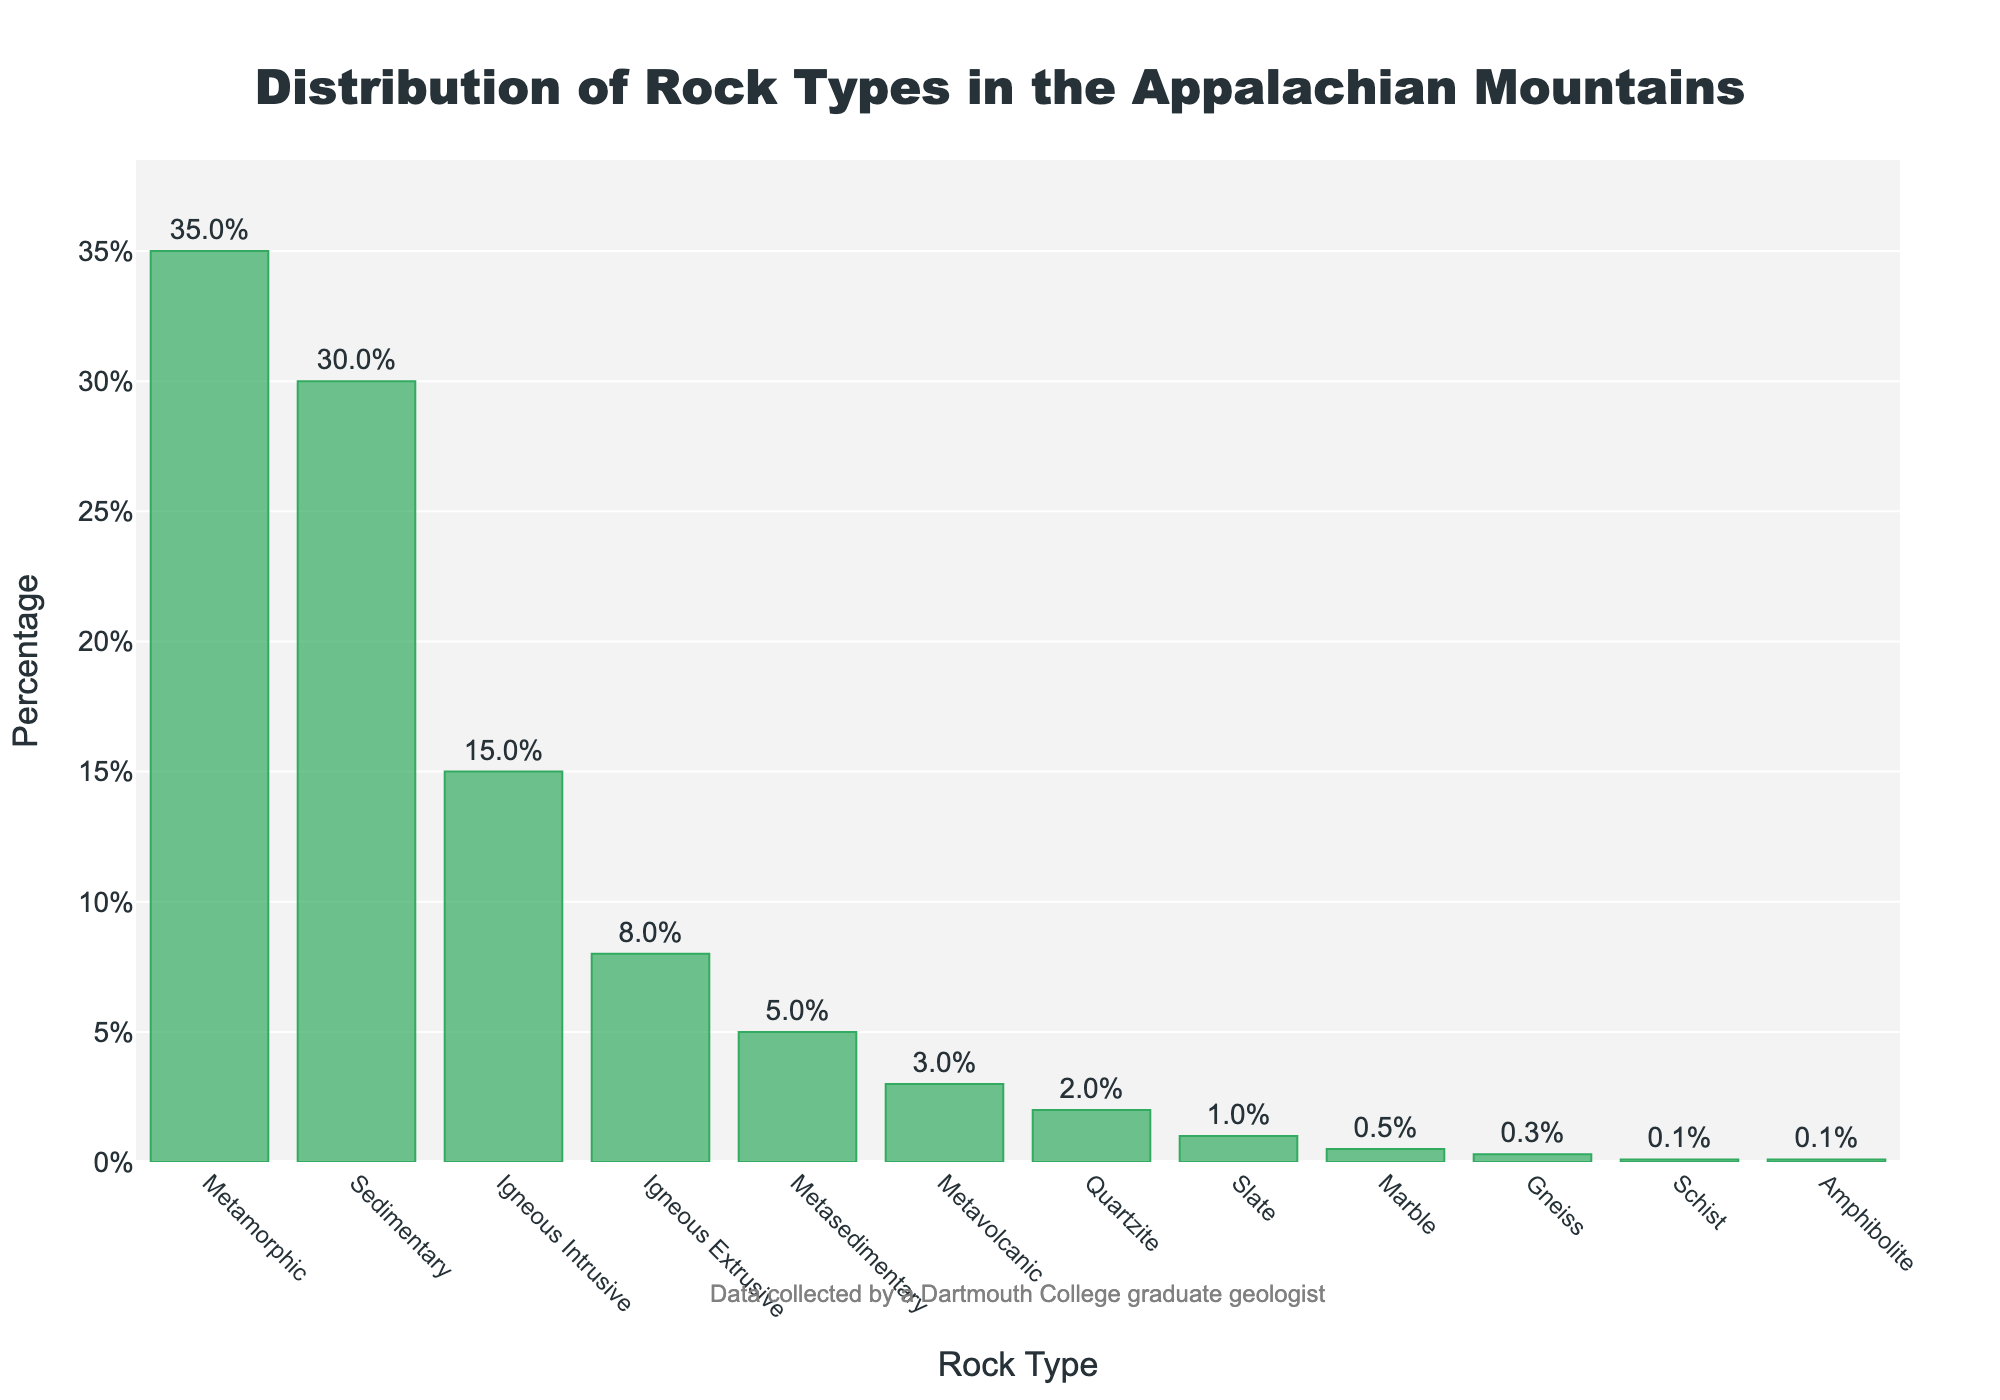What is the most common rock type in the Appalachian Mountains? The highest bar on the chart represents the most common rock type. The tallest bar corresponds to Metamorphic rock, which has the highest percentage.
Answer: Metamorphic Which rock type has the smallest representation in the distribution? The shortest bar on the chart represents the least common rock type. The smallest bar corresponds to Schist and Amphibolite, both with 0.1%.
Answer: Schist and Amphibolite How many rock types have a representation of less than 5% in the distribution? Identify the bars that are less than 5% along the y-axis. There are 7 such bars: Metasedimentary, Metavolcanic, Quartzite, Slate, Marble, Gneiss, Schist, and Amphibolite.
Answer: 7 What is the combined percentage of Igneous Intrusive and Igneous Extrusive rocks? Add the percentage values of Igneous Intrusive (15%) and Igneous Extrusive (8%). 15% + 8% = 23%.
Answer: 23% Compare the percentage representation of Sedimentary and Metasedimentary rocks. Refer to the height of the bars for Sedimentary (30%) and Metasedimentary (5%). Sedimentary rock has a higher percentage.
Answer: Sedimentary Is the percentage of Metamorphic rock greater than the combined percentage of Metasedimentary and Metavolcanic rocks? Metamorphic is 35%. Metasedimentary (5%) + Metavolcanic (3%) = 8%. Yes, 35% is greater than 8%.
Answer: Yes Which has a higher percentage, Quartzite or Marble? Compare the heights of the bars for Quartzite (2%) and Marble (0.5%). Quartzite has a higher percentage.
Answer: Quartzite What is the average percentage of Sedimentary, Igneous Intrusive, and Igneous Extrusive rocks? Add the percentages and divide by the number of rock types: (30% + 15% + 8%) / 3. The sum is 53%, and the average is 53% / 3 ≈ 17.67%.
Answer: 17.67% Which rock type is closest in percentage to Slate? Compare the bars' heights and find the one closest to Slate (1%). Marble is closest with 0.5%.
Answer: Marble 